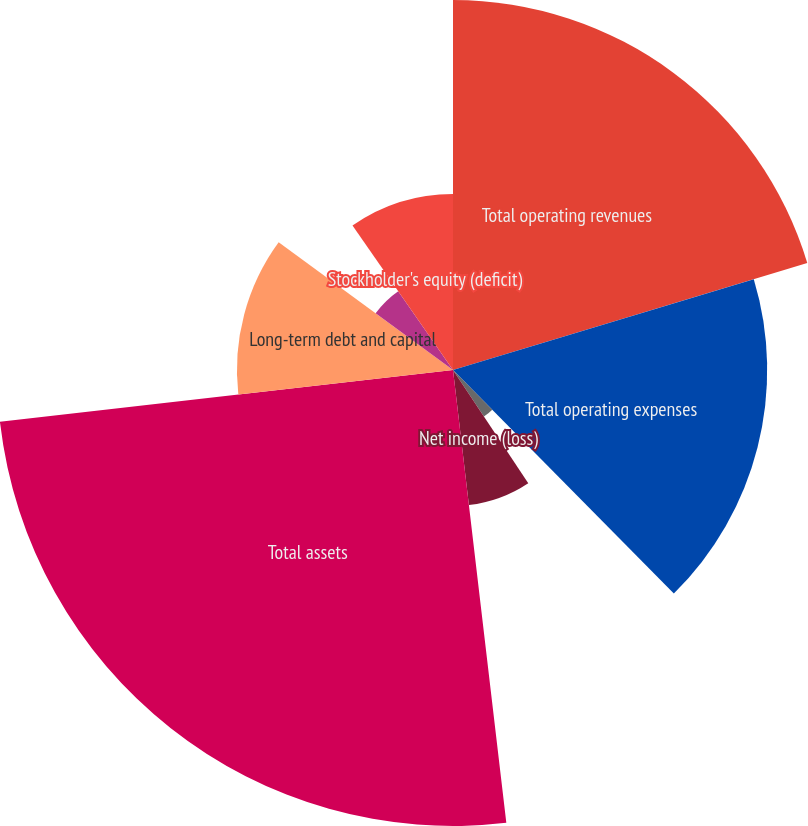<chart> <loc_0><loc_0><loc_500><loc_500><pie_chart><fcel>Total operating revenues<fcel>Total operating expenses<fcel>Operating income<fcel>Net income (loss)<fcel>Total assets<fcel>Long-term debt and capital<fcel>Pension and postretirement<fcel>Stockholder's equity (deficit)<nl><fcel>20.33%<fcel>17.26%<fcel>3.07%<fcel>7.47%<fcel>25.05%<fcel>11.87%<fcel>5.27%<fcel>9.67%<nl></chart> 